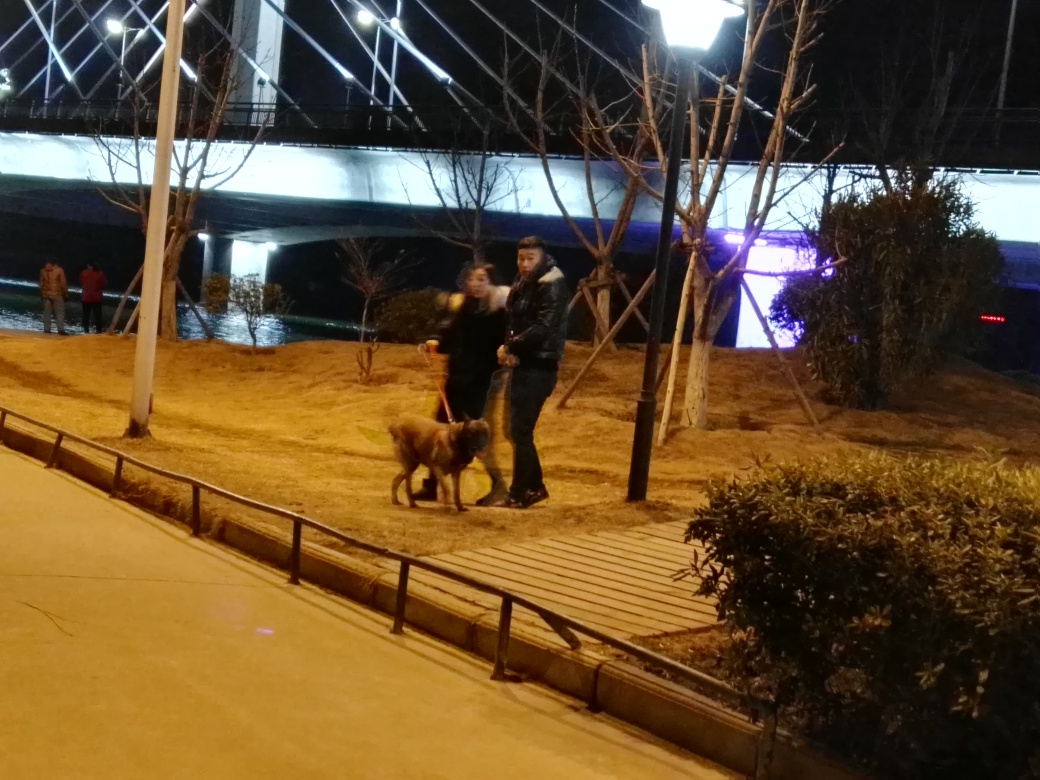What activities are the people in the image engaged in? The people in the photo appear to be engaged in a casual walk with their dog. One person appears to be handling the dog's leash, suggesting they are likely focusing on pet care and leisure. 